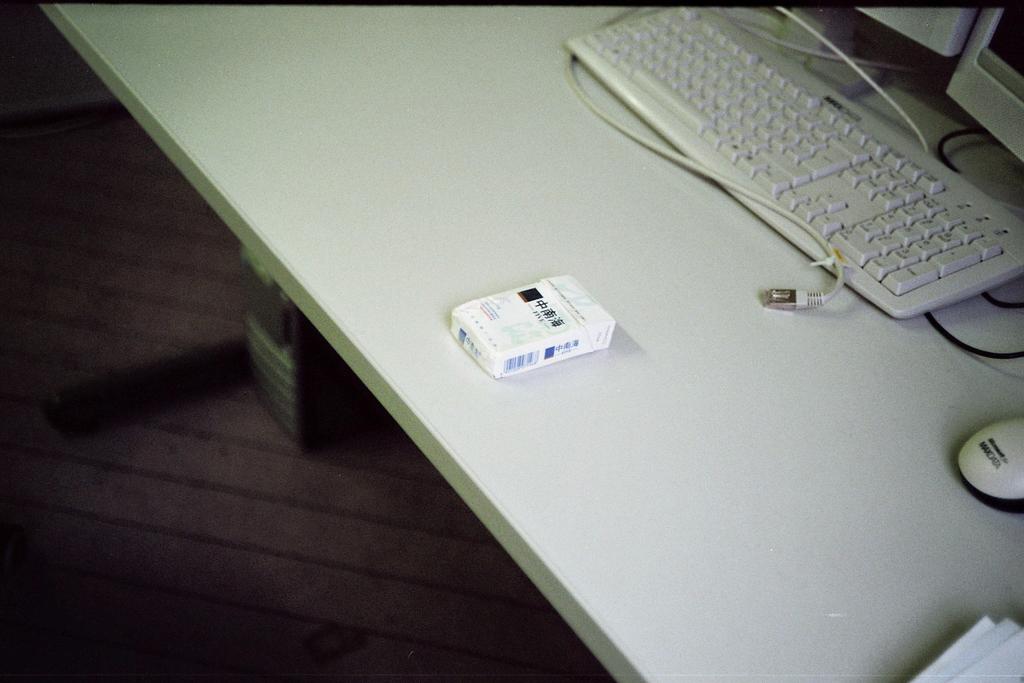What is written on the mouse?
Offer a terse response. Maxdata. 